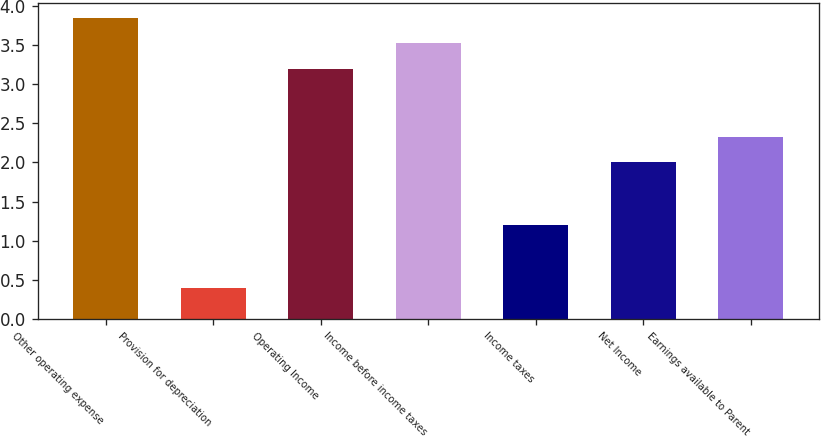<chart> <loc_0><loc_0><loc_500><loc_500><bar_chart><fcel>Other operating expense<fcel>Provision for depreciation<fcel>Operating Income<fcel>Income before income taxes<fcel>Income taxes<fcel>Net Income<fcel>Earnings available to Parent<nl><fcel>3.84<fcel>0.4<fcel>3.2<fcel>3.52<fcel>1.2<fcel>2<fcel>2.32<nl></chart> 